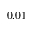<formula> <loc_0><loc_0><loc_500><loc_500>0 . 0 1</formula> 